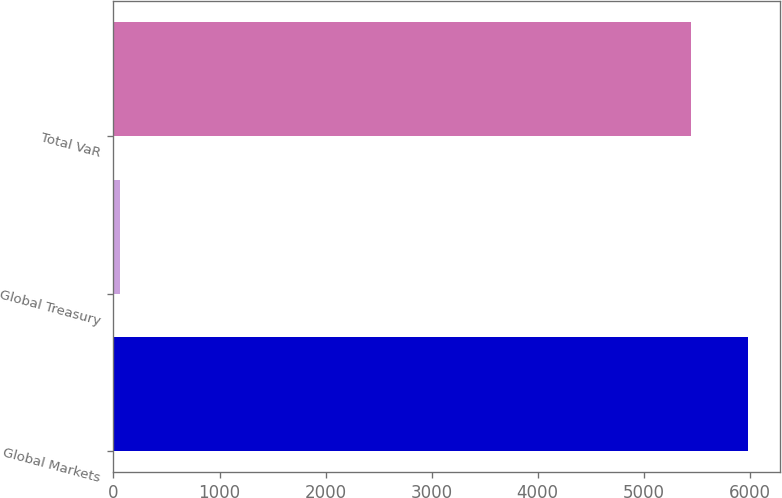Convert chart to OTSL. <chart><loc_0><loc_0><loc_500><loc_500><bar_chart><fcel>Global Markets<fcel>Global Treasury<fcel>Total VaR<nl><fcel>5981.5<fcel>58<fcel>5441<nl></chart> 